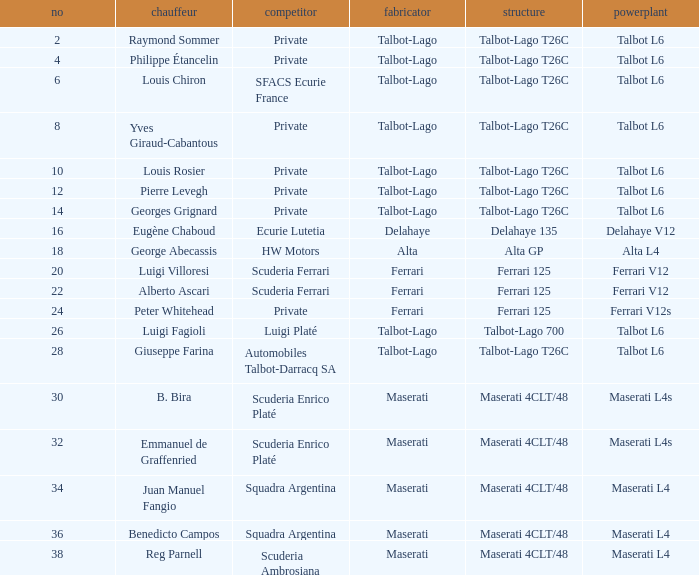Name the chassis for b. bira Maserati 4CLT/48. 